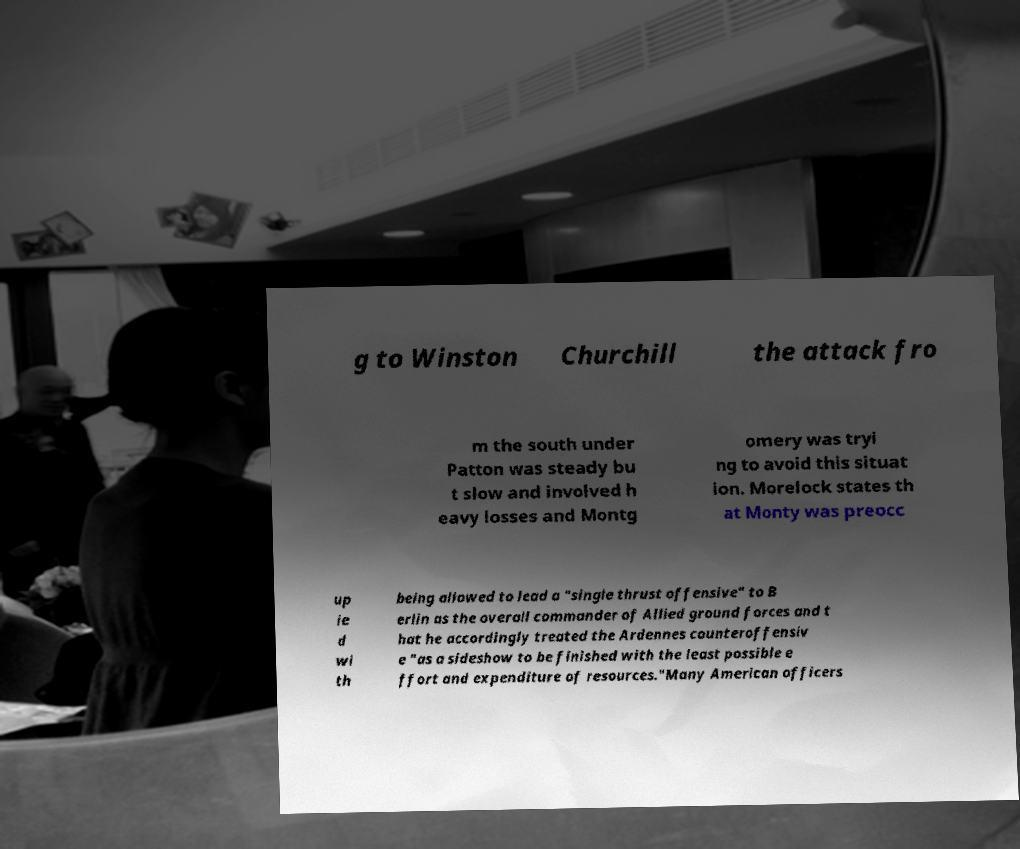I need the written content from this picture converted into text. Can you do that? g to Winston Churchill the attack fro m the south under Patton was steady bu t slow and involved h eavy losses and Montg omery was tryi ng to avoid this situat ion. Morelock states th at Monty was preocc up ie d wi th being allowed to lead a "single thrust offensive" to B erlin as the overall commander of Allied ground forces and t hat he accordingly treated the Ardennes counteroffensiv e "as a sideshow to be finished with the least possible e ffort and expenditure of resources."Many American officers 